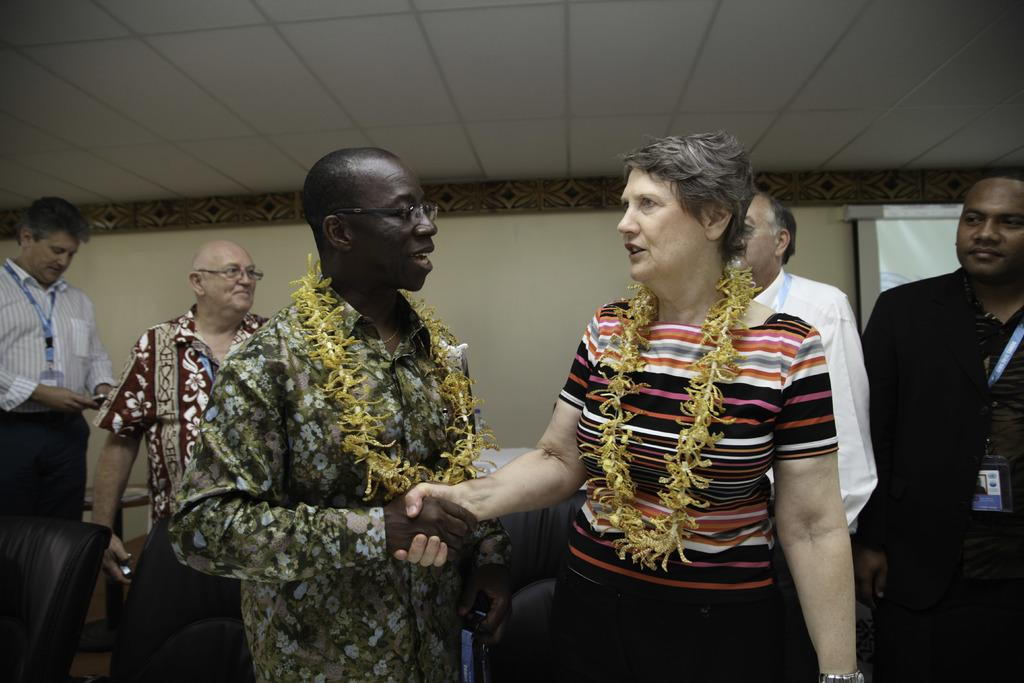How many people are in the image? There are two people in the image. What are the two people wearing? The two people are wearing garlands. What are the two people doing in the image? The two people are standing. What can be seen in the background of the image? There is a wall, a ceiling, a screen, and other objects visible in the background of the image. Are there any other people visible in the image? Yes, there are other people visible in the background of the image. What type of story is being told by the cattle in the image? There are no cattle present in the image, so no story can be told by them. How many wheels can be seen on the objects in the image? There is: There is no wheel visible in the image. 